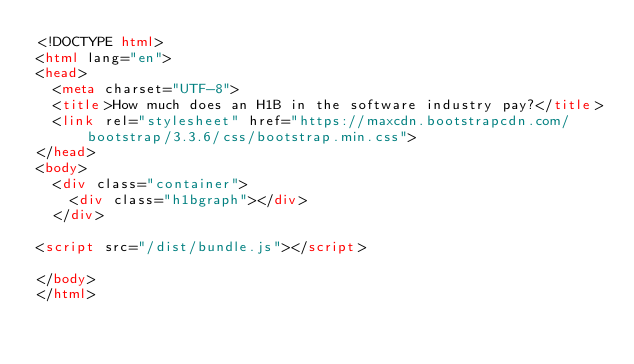Convert code to text. <code><loc_0><loc_0><loc_500><loc_500><_HTML_><!DOCTYPE html>
<html lang="en">
<head>
  <meta charset="UTF-8">
  <title>How much does an H1B in the software industry pay?</title>
  <link rel="stylesheet" href="https://maxcdn.bootstrapcdn.com/bootstrap/3.3.6/css/bootstrap.min.css">
</head>
<body>
  <div class="container">
    <div class="h1bgraph"></div>
  </div>

<script src="/dist/bundle.js"></script>

</body>
</html>
</code> 